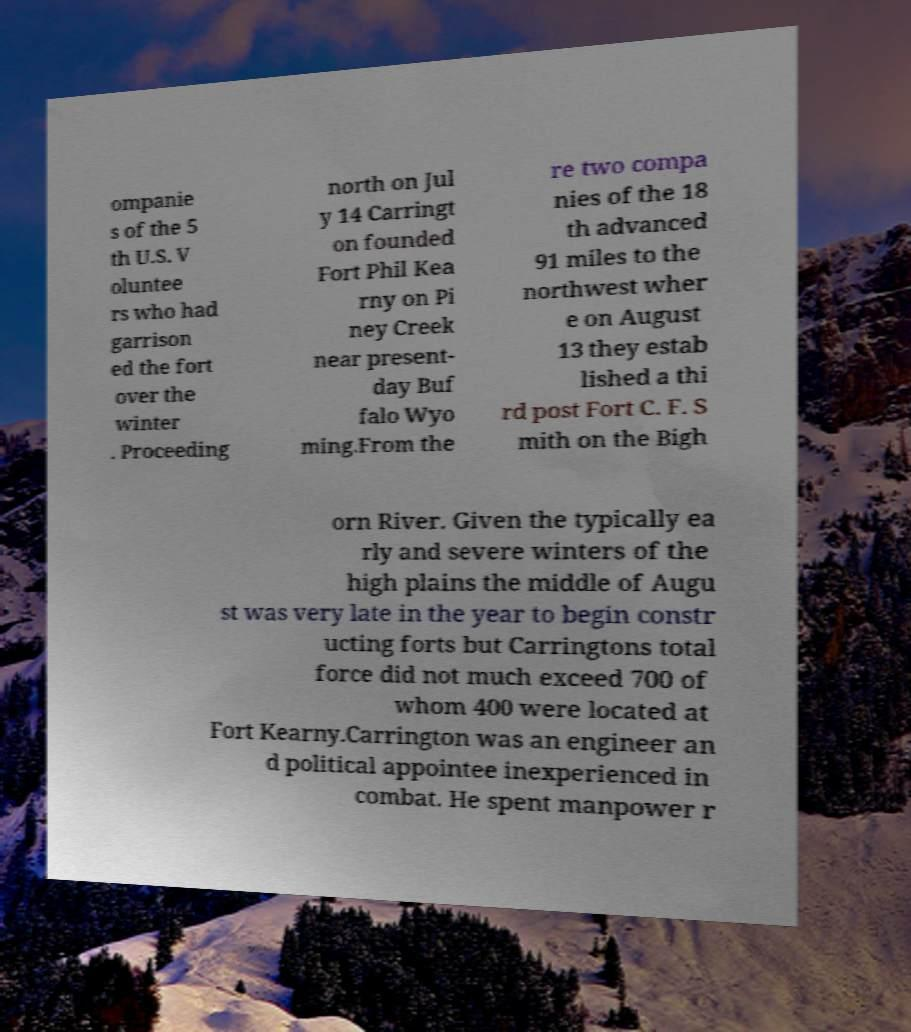Can you read and provide the text displayed in the image?This photo seems to have some interesting text. Can you extract and type it out for me? ompanie s of the 5 th U.S. V oluntee rs who had garrison ed the fort over the winter . Proceeding north on Jul y 14 Carringt on founded Fort Phil Kea rny on Pi ney Creek near present- day Buf falo Wyo ming.From the re two compa nies of the 18 th advanced 91 miles to the northwest wher e on August 13 they estab lished a thi rd post Fort C. F. S mith on the Bigh orn River. Given the typically ea rly and severe winters of the high plains the middle of Augu st was very late in the year to begin constr ucting forts but Carringtons total force did not much exceed 700 of whom 400 were located at Fort Kearny.Carrington was an engineer an d political appointee inexperienced in combat. He spent manpower r 